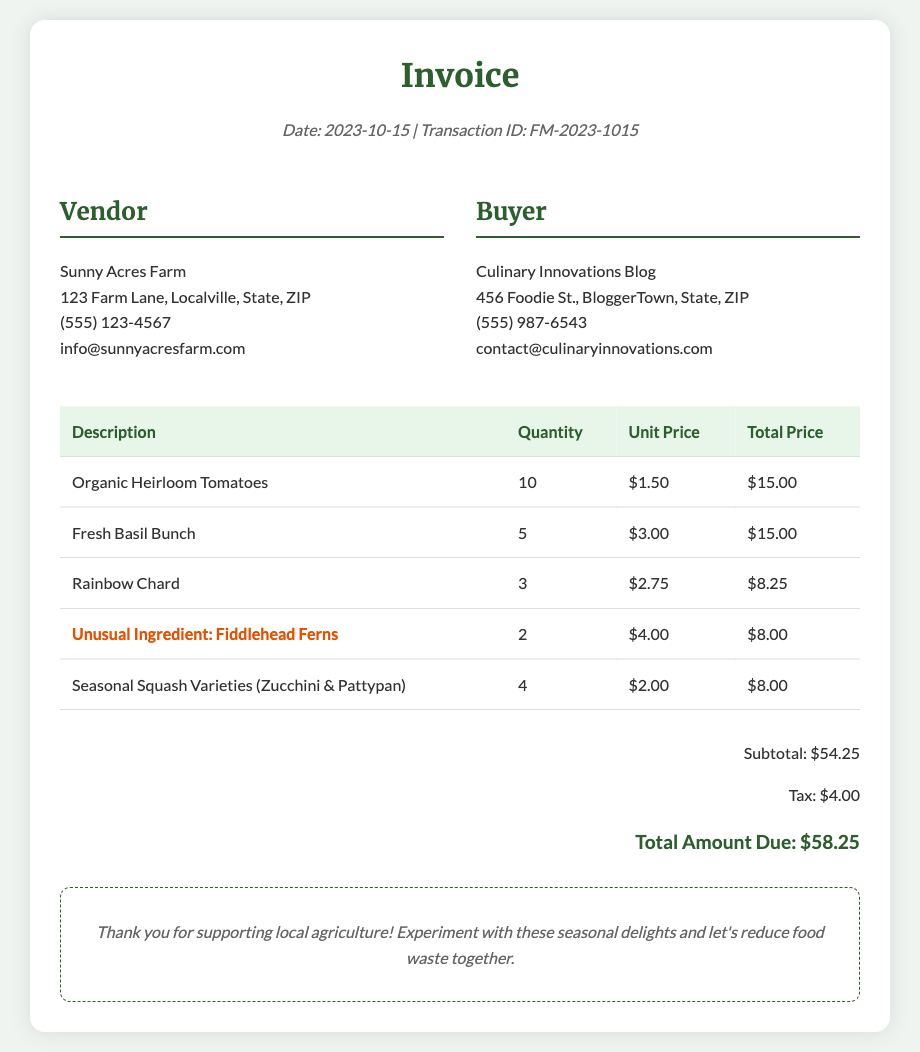What is the date of the transaction? The date of the transaction is mentioned in the document as “2023-10-15”.
Answer: 2023-10-15 Who is the vendor? The vendor's name is provided in the document under the vendor section.
Answer: Sunny Acres Farm What is the total amount due? The total amount due is mentioned in the summary section at the end of the document.
Answer: $58.25 How many quantities of Fresh Basil Bunch were purchased? The quantity of Fresh Basil Bunch is listed in the table of purchased items.
Answer: 5 What is the unusual ingredient listed in the invoice? The document specifies an unusual ingredient in one of the rows of the table.
Answer: Fiddlehead Ferns Which seasonal produce variety is included in the invoice? The document mentions seasonal squash varieties in the list of purchased items.
Answer: Zucchini & Pattypan What is the subtotal amount before tax? The subtotal is provided in the summary section of the document before tax is added.
Answer: $54.25 How many Fiddlehead Ferns were purchased? The quantity of Fiddlehead Ferns is stated in the invoice table.
Answer: 2 What is the buyer's email address? The buyer's email address is provided in the buyer details section.
Answer: contact@culinaryinnovations.com 